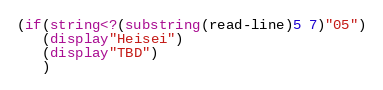Convert code to text. <code><loc_0><loc_0><loc_500><loc_500><_Scheme_>(if(string<?(substring(read-line)5 7)"05")
   (display"Heisei")
   (display"TBD")
   )
</code> 